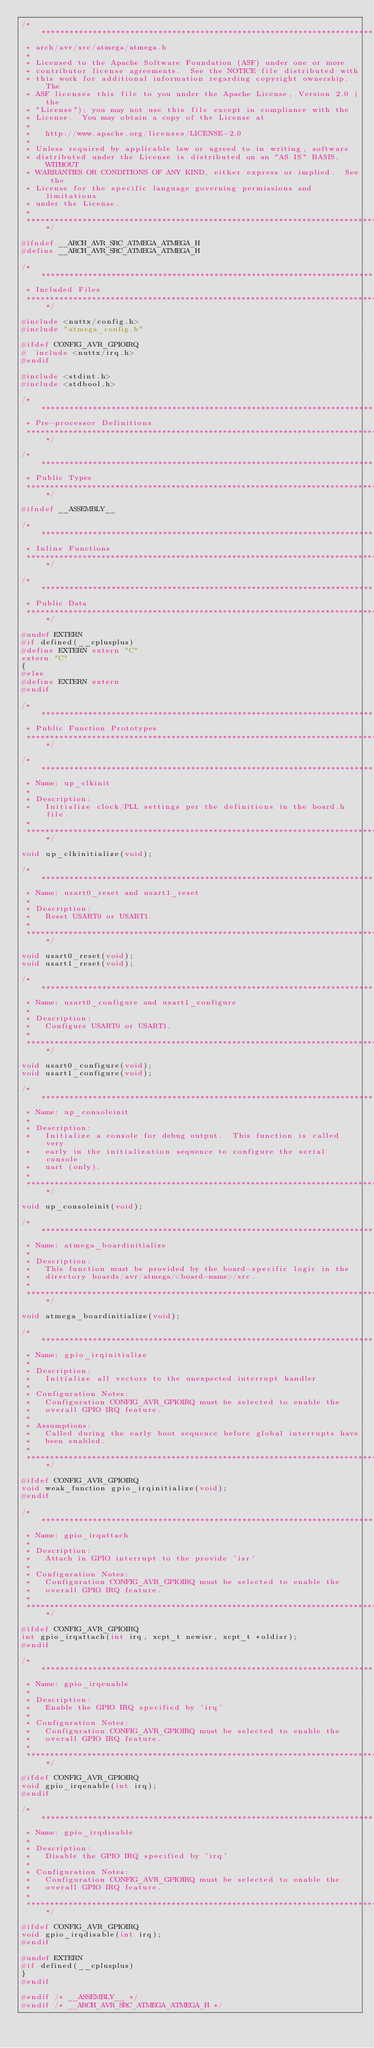<code> <loc_0><loc_0><loc_500><loc_500><_C_>/****************************************************************************
 * arch/avr/src/atmega/atmega.h
 *
 * Licensed to the Apache Software Foundation (ASF) under one or more
 * contributor license agreements.  See the NOTICE file distributed with
 * this work for additional information regarding copyright ownership.  The
 * ASF licenses this file to you under the Apache License, Version 2.0 (the
 * "License"); you may not use this file except in compliance with the
 * License.  You may obtain a copy of the License at
 *
 *   http://www.apache.org/licenses/LICENSE-2.0
 *
 * Unless required by applicable law or agreed to in writing, software
 * distributed under the License is distributed on an "AS IS" BASIS, WITHOUT
 * WARRANTIES OR CONDITIONS OF ANY KIND, either express or implied.  See the
 * License for the specific language governing permissions and limitations
 * under the License.
 *
 ****************************************************************************/

#ifndef __ARCH_AVR_SRC_ATMEGA_ATMEGA_H
#define __ARCH_AVR_SRC_ATMEGA_ATMEGA_H

/****************************************************************************
 * Included Files
 ****************************************************************************/

#include <nuttx/config.h>
#include "atmega_config.h"

#ifdef CONFIG_AVR_GPIOIRQ
#  include <nuttx/irq.h>
#endif

#include <stdint.h>
#include <stdbool.h>

/****************************************************************************
 * Pre-processor Definitions
 ****************************************************************************/

/****************************************************************************
 * Public Types
 ****************************************************************************/

#ifndef __ASSEMBLY__

/****************************************************************************
 * Inline Functions
 ****************************************************************************/

/****************************************************************************
 * Public Data
 ****************************************************************************/

#undef EXTERN
#if defined(__cplusplus)
#define EXTERN extern "C"
extern "C"
{
#else
#define EXTERN extern
#endif

/****************************************************************************
 * Public Function Prototypes
 ****************************************************************************/

/****************************************************************************
 * Name: up_clkinit
 *
 * Description:
 *   Initialize clock/PLL settings per the definitions in the board.h file.
 *
 ****************************************************************************/

void up_clkinitialize(void);

/****************************************************************************
 * Name: usart0_reset and usart1_reset
 *
 * Description:
 *   Reset USART0 or USART1.
 *
 ****************************************************************************/

void usart0_reset(void);
void usart1_reset(void);

/****************************************************************************
 * Name: usart0_configure and usart1_configure
 *
 * Description:
 *   Configure USART0 or USART1.
 *
 ****************************************************************************/

void usart0_configure(void);
void usart1_configure(void);

/****************************************************************************
 * Name: up_consoleinit
 *
 * Description:
 *   Initialize a console for debug output.  This function is called very
 *   early in the initialization sequence to configure the serial console
 *   uart (only).
 *
 ****************************************************************************/

void up_consoleinit(void);

/****************************************************************************
 * Name: atmega_boardinitialize
 *
 * Description:
 *   This function must be provided by the board-specific logic in the
 *   directory boards/avr/atmega/<board-name>/src.
 *
 ****************************************************************************/

void atmega_boardinitialize(void);

/****************************************************************************
 * Name: gpio_irqinitialize
 *
 * Description:
 *   Initialize all vectors to the unexpected interrupt handler
 *
 * Configuration Notes:
 *   Configuration CONFIG_AVR_GPIOIRQ must be selected to enable the
 *   overall GPIO IRQ feature.
 *
 * Assumptions:
 *   Called during the early boot sequence before global interrupts have
 *   been enabled.
 *
 ****************************************************************************/

#ifdef CONFIG_AVR_GPIOIRQ
void weak_function gpio_irqinitialize(void);
#endif

/****************************************************************************
 * Name: gpio_irqattach
 *
 * Description:
 *   Attach in GPIO interrupt to the provide 'isr'
 *
 * Configuration Notes:
 *   Configuration CONFIG_AVR_GPIOIRQ must be selected to enable the
 *   overall GPIO IRQ feature.
 *
 ****************************************************************************/

#ifdef CONFIG_AVR_GPIOIRQ
int gpio_irqattach(int irq, xcpt_t newisr, xcpt_t *oldisr);
#endif

/****************************************************************************
 * Name: gpio_irqenable
 *
 * Description:
 *   Enable the GPIO IRQ specified by 'irq'
 *
 * Configuration Notes:
 *   Configuration CONFIG_AVR_GPIOIRQ must be selected to enable the
 *   overall GPIO IRQ feature.
 *
 ****************************************************************************/

#ifdef CONFIG_AVR_GPIOIRQ
void gpio_irqenable(int irq);
#endif

/****************************************************************************
 * Name: gpio_irqdisable
 *
 * Description:
 *   Disable the GPIO IRQ specified by 'irq'
 *
 * Configuration Notes:
 *   Configuration CONFIG_AVR_GPIOIRQ must be selected to enable the
 *   overall GPIO IRQ feature.
 *
 ****************************************************************************/

#ifdef CONFIG_AVR_GPIOIRQ
void gpio_irqdisable(int irq);
#endif

#undef EXTERN
#if defined(__cplusplus)
}
#endif

#endif /* __ASSEMBLY__ */
#endif /* __ARCH_AVR_SRC_ATMEGA_ATMEGA_H */
</code> 